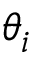<formula> <loc_0><loc_0><loc_500><loc_500>\theta _ { i }</formula> 